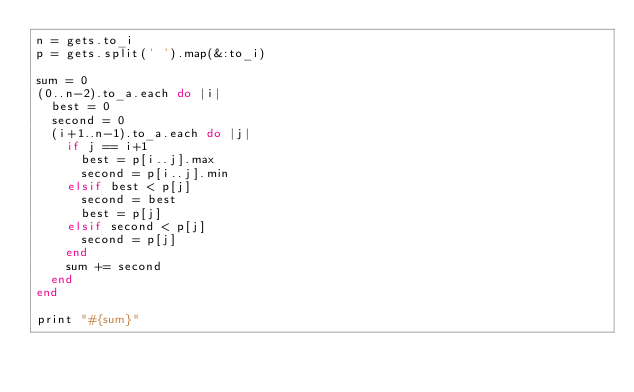<code> <loc_0><loc_0><loc_500><loc_500><_Ruby_>n = gets.to_i
p = gets.split(' ').map(&:to_i)

sum = 0
(0..n-2).to_a.each do |i|
  best = 0
  second = 0
  (i+1..n-1).to_a.each do |j|
    if j == i+1
      best = p[i..j].max
      second = p[i..j].min
    elsif best < p[j]
      second = best
      best = p[j]
    elsif second < p[j]
      second = p[j]
    end
    sum += second
  end
end

print "#{sum}"
</code> 